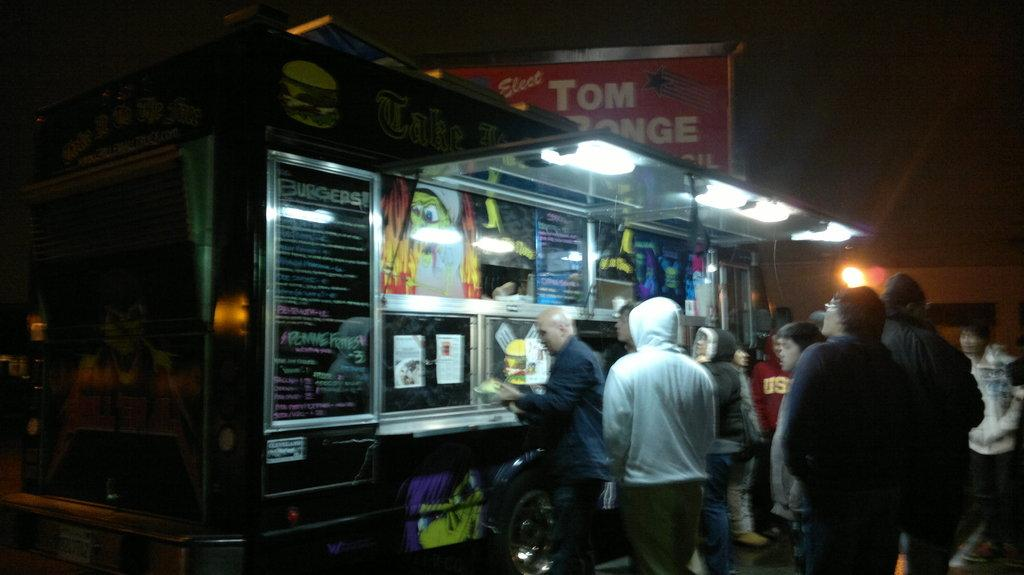What type of vehicle is present in the image? There is a food truck in the image. What can be seen illuminated in the image? There are lights in the image. What type of signage is present in the image? There are posters and a banner in the image. Are there any people present in the image? Yes, there are people in the image. What part of the natural environment is visible in the image? The sky is visible in the image. How would you describe the overall lighting in the image? The image is slightly dark. Where is the aunt sitting with her cushion in the image? There is no aunt or cushion present in the image. How many mice can be seen running around the food truck in the image? There are no mice present in the image. 